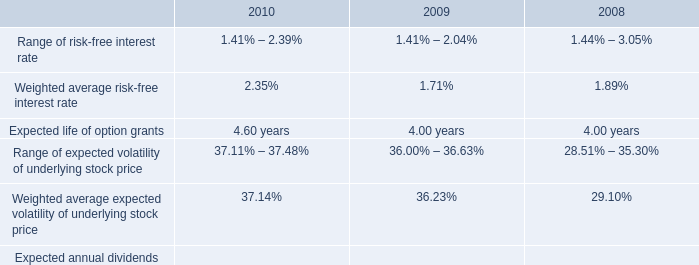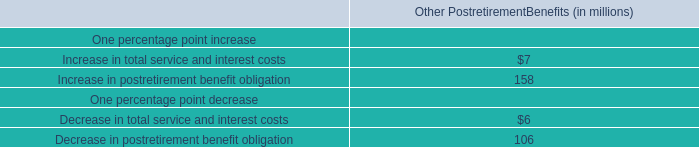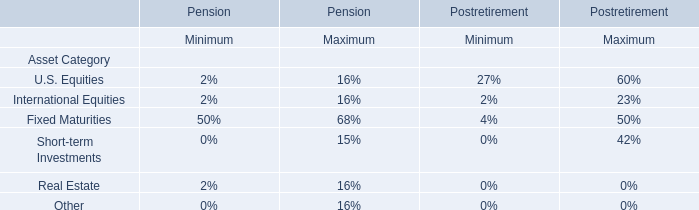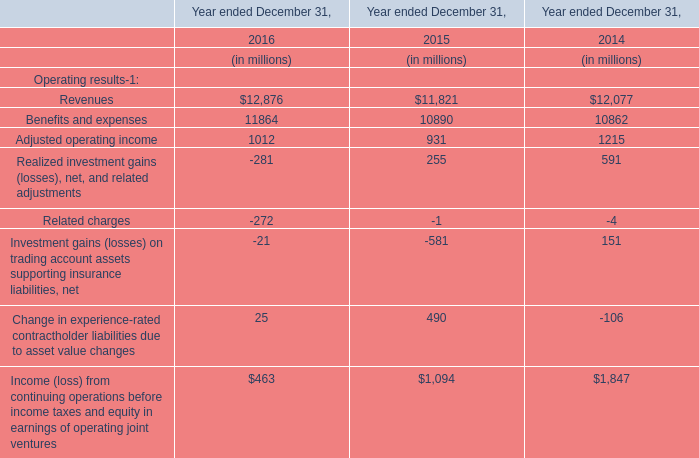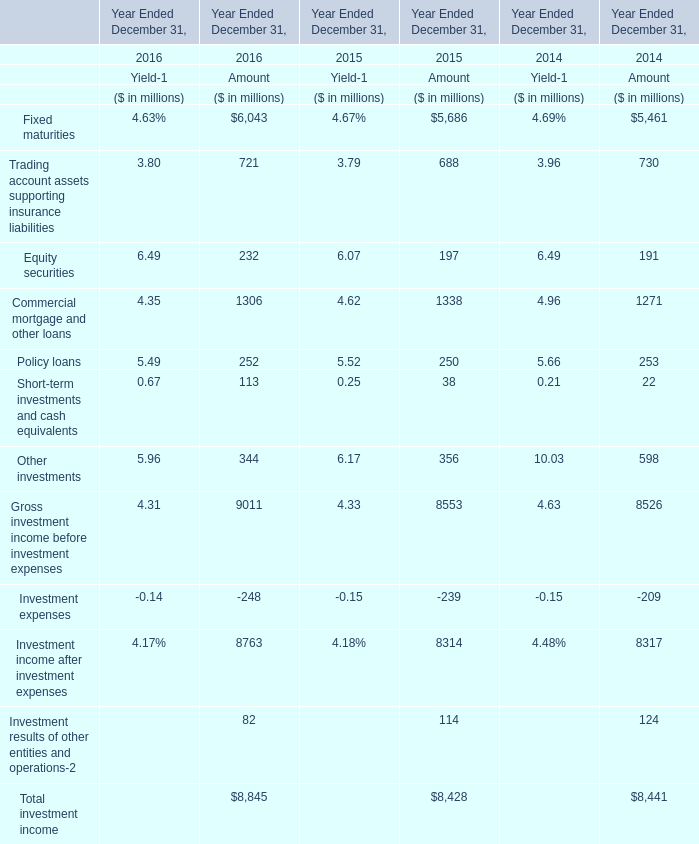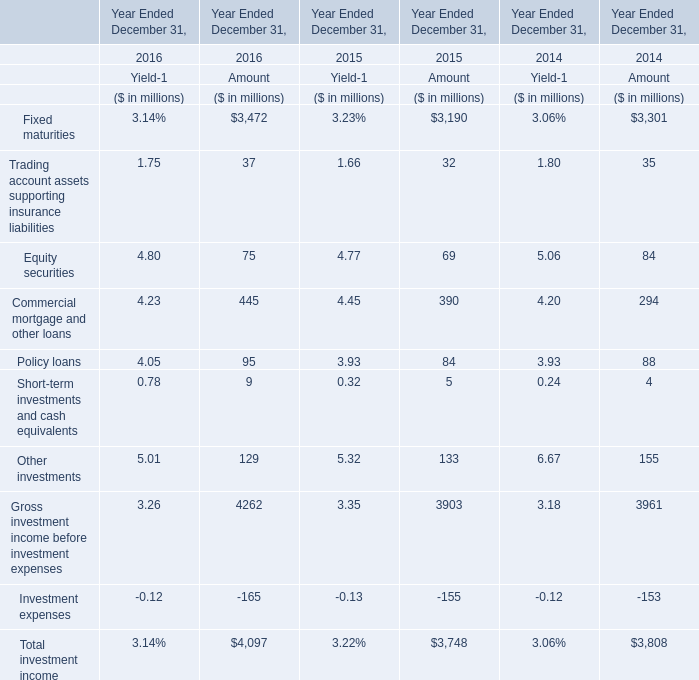what is the highest total amount of rading account assets supporting insurance liabilities? (in million) 
Computations: (3.8 + 721)
Answer: 724.8. 